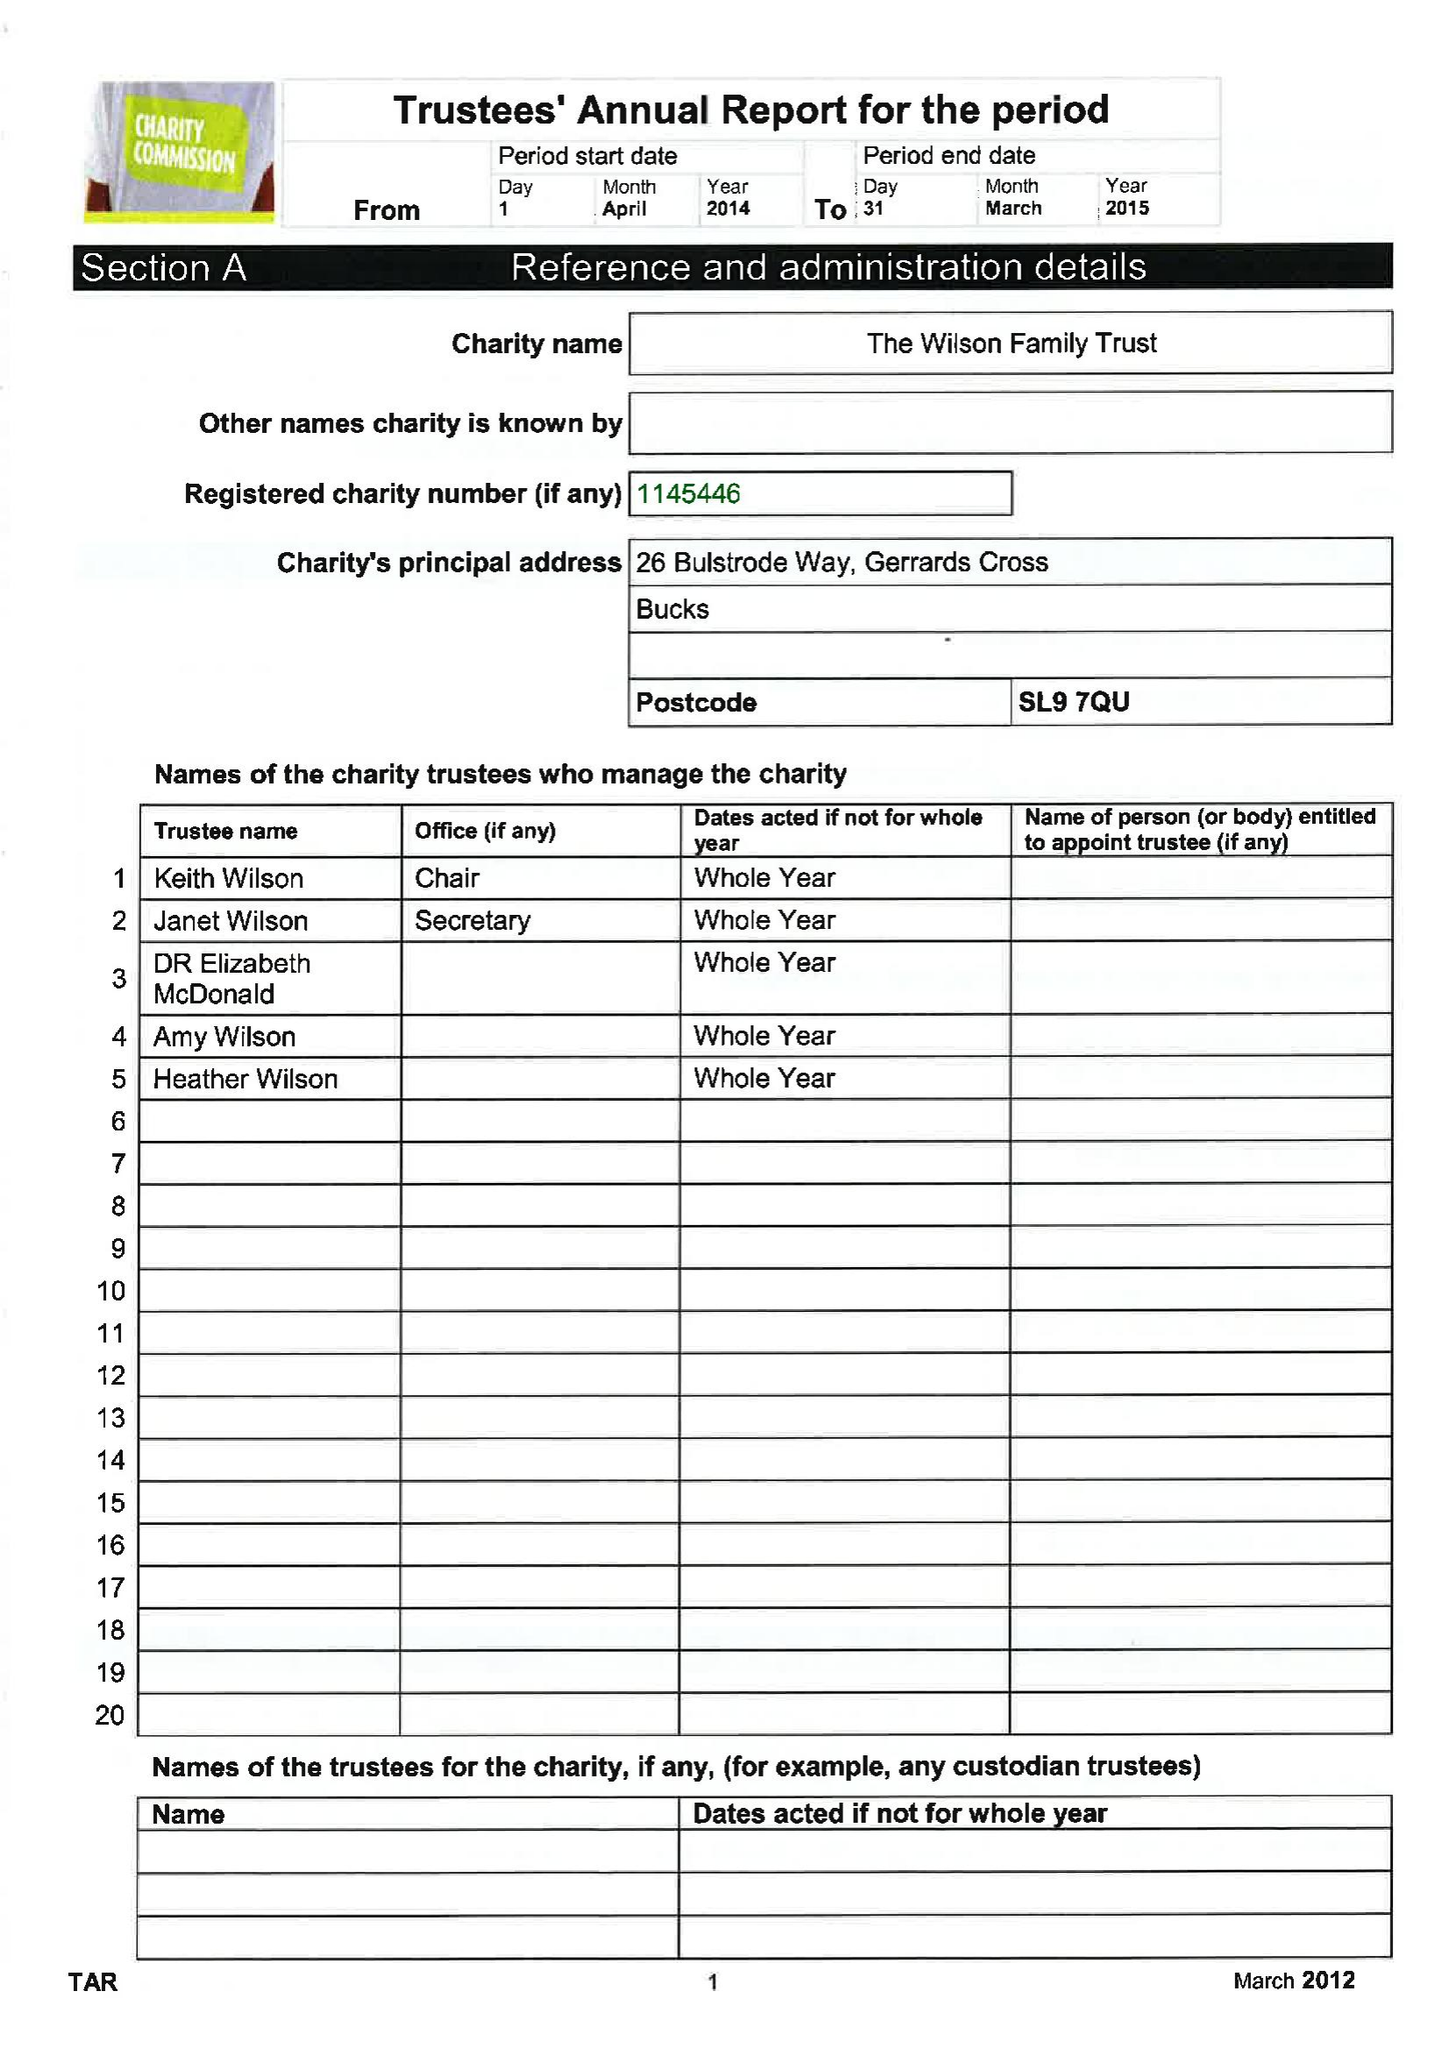What is the value for the address__post_town?
Answer the question using a single word or phrase. GERRARDS CROSS 